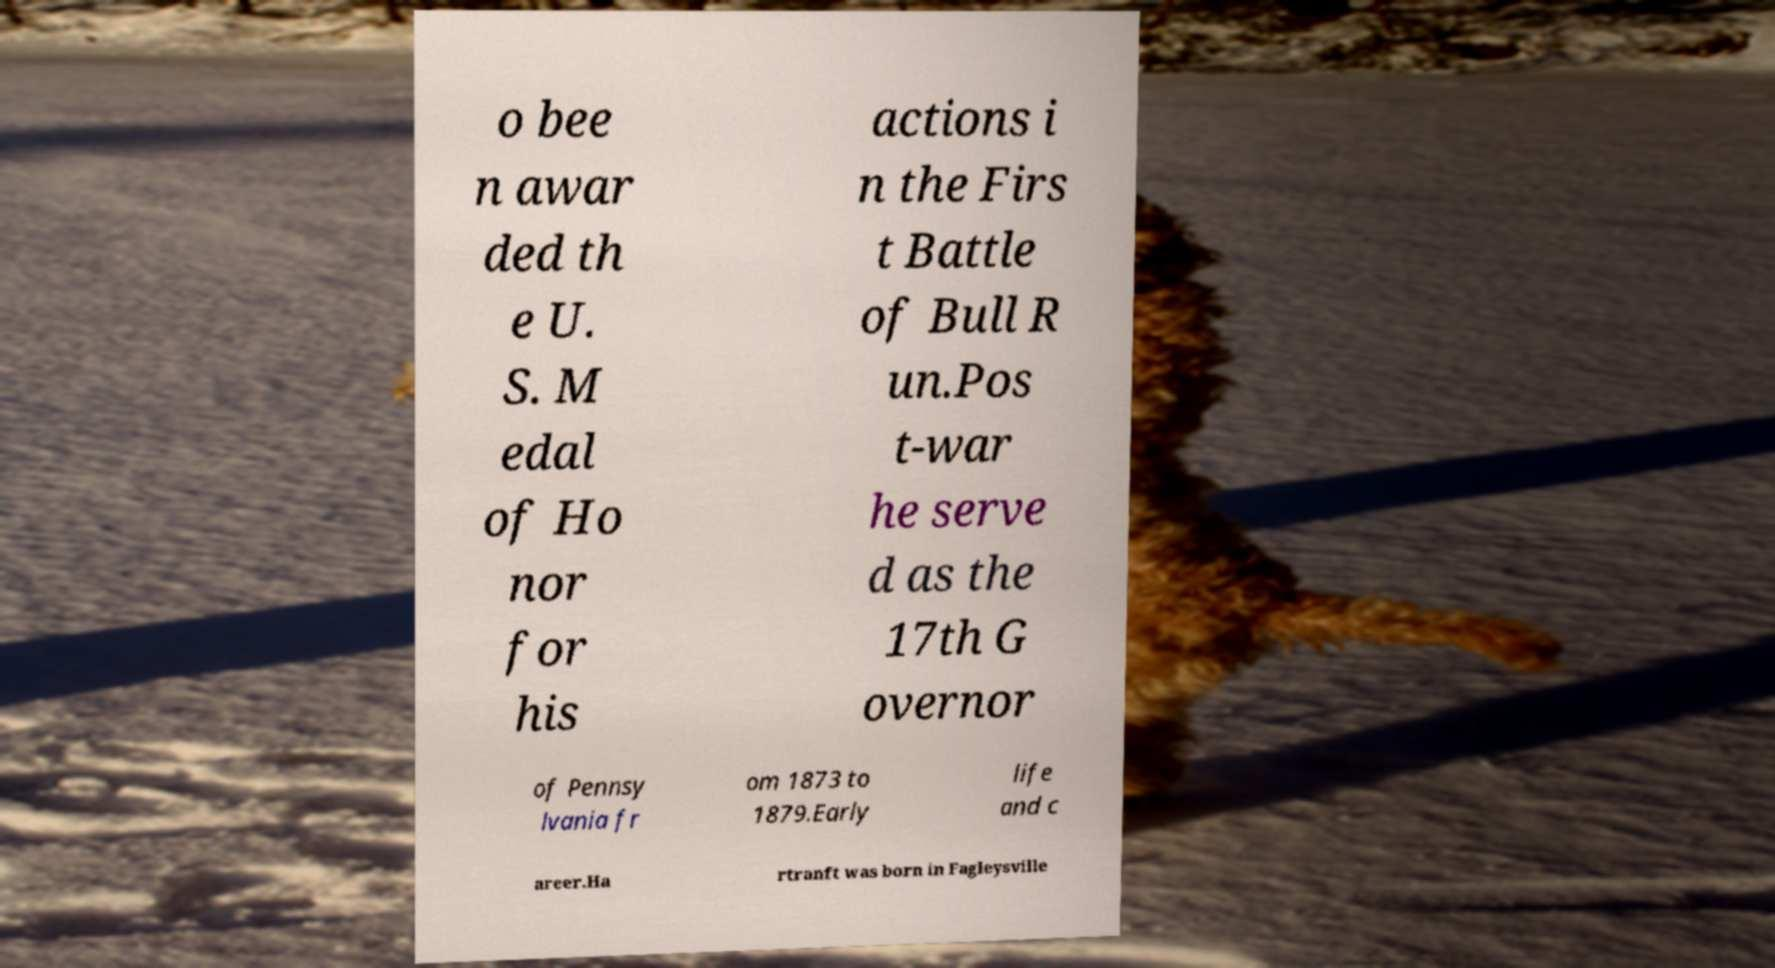Could you extract and type out the text from this image? o bee n awar ded th e U. S. M edal of Ho nor for his actions i n the Firs t Battle of Bull R un.Pos t-war he serve d as the 17th G overnor of Pennsy lvania fr om 1873 to 1879.Early life and c areer.Ha rtranft was born in Fagleysville 